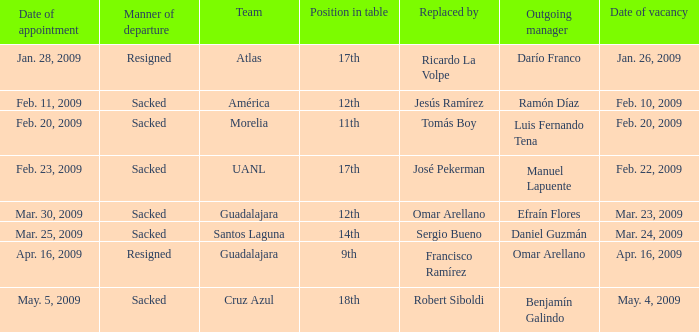What is Position in Table, when Replaced By is "Sergio Bueno"? 14th. 